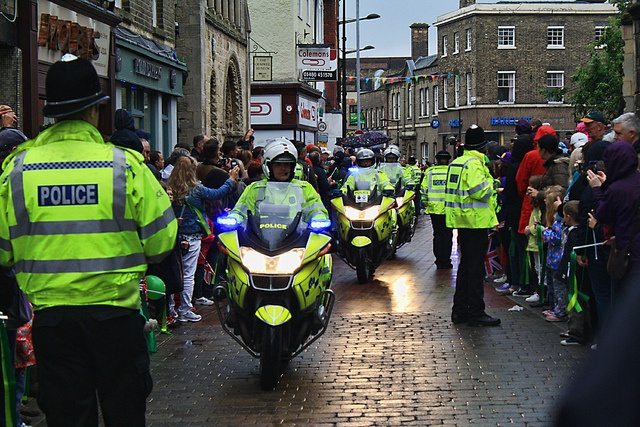Describe the objects in this image and their specific colors. I can see people in black, green, lightgreen, and lime tones, people in black, maroon, gray, and navy tones, motorcycle in black, white, navy, and darkgreen tones, people in black, lightgreen, lime, and green tones, and motorcycle in black, white, darkgreen, and gray tones in this image. 